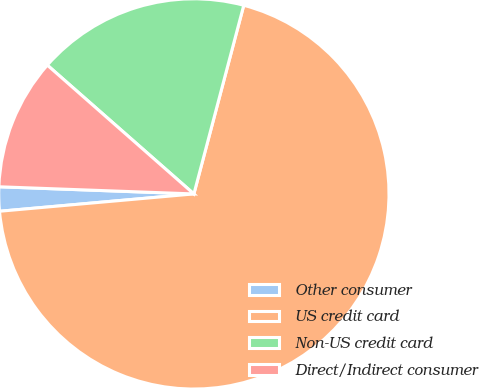<chart> <loc_0><loc_0><loc_500><loc_500><pie_chart><fcel>Other consumer<fcel>US credit card<fcel>Non-US credit card<fcel>Direct/Indirect consumer<nl><fcel>2.0%<fcel>69.47%<fcel>17.64%<fcel>10.89%<nl></chart> 